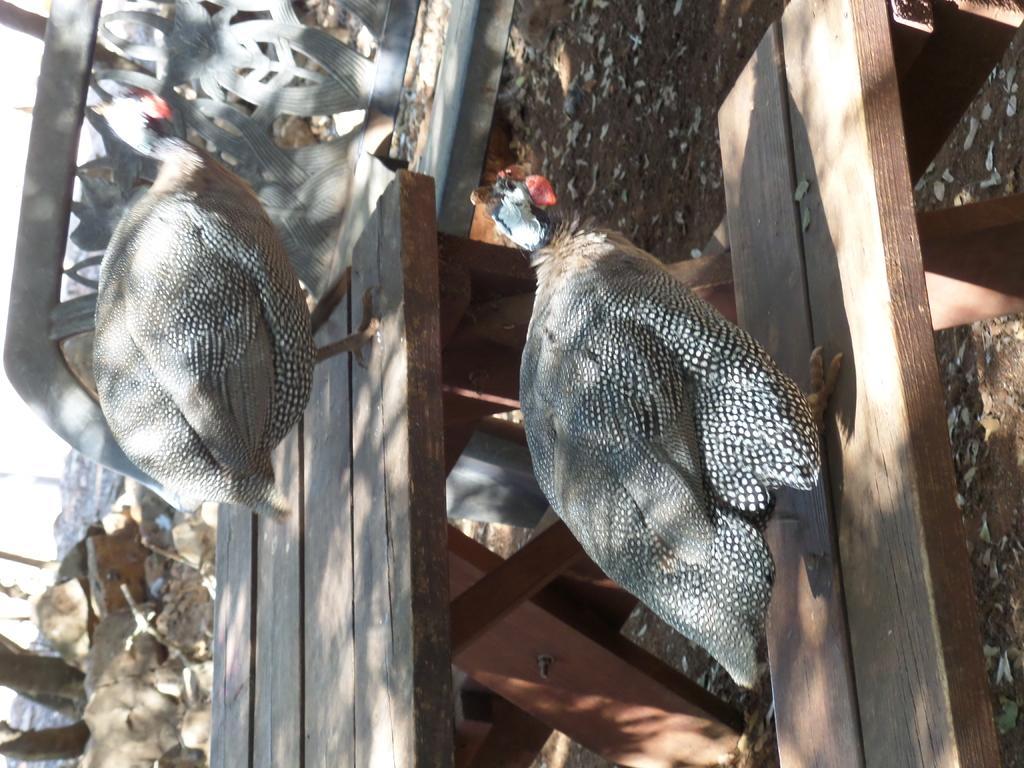In one or two sentences, can you explain what this image depicts? In this image I can see a bench in the front and on it I can see two birds. On the top left side of this image I can see a cement thing. On the bottom left side I can see few stuffs on the ground. 